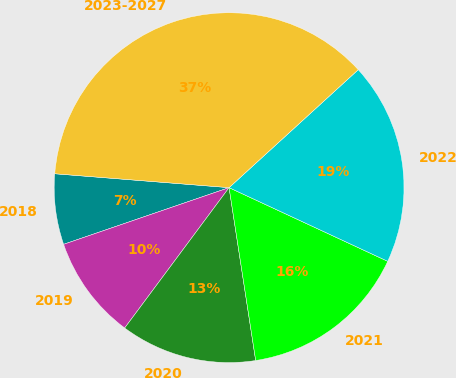<chart> <loc_0><loc_0><loc_500><loc_500><pie_chart><fcel>2018<fcel>2019<fcel>2020<fcel>2021<fcel>2022<fcel>2023-2027<nl><fcel>6.52%<fcel>9.57%<fcel>12.61%<fcel>15.65%<fcel>18.7%<fcel>36.96%<nl></chart> 